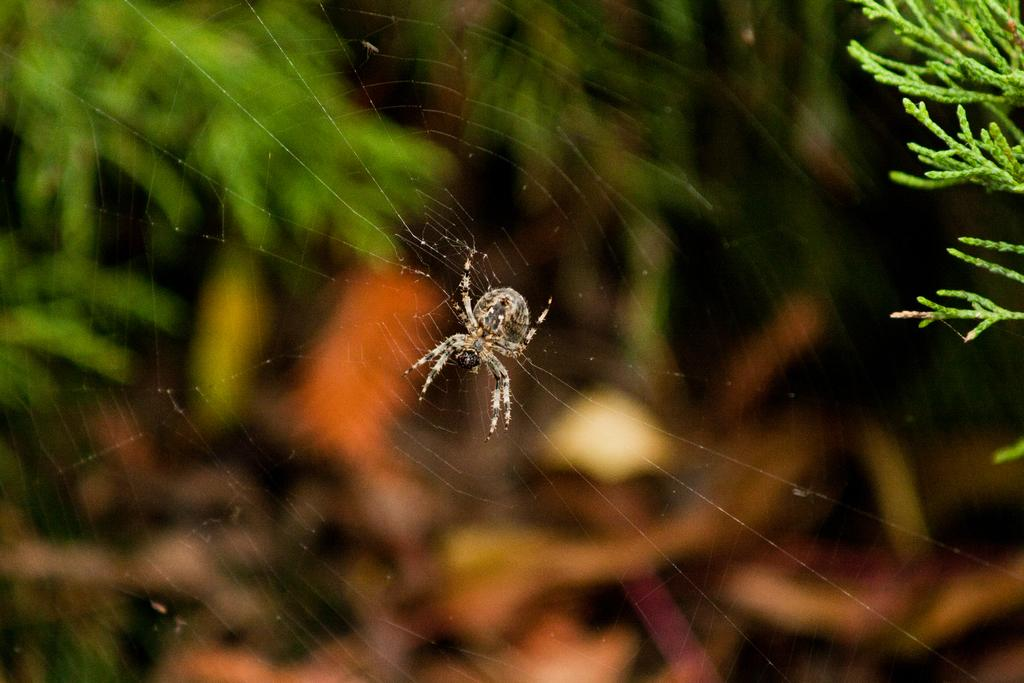What is the main subject of the image? The main subject of the image is a spider. Where is the spider located in the image? The spider is on a web. What can be seen on the right side of the image? There are leaves on the right side of the image. How would you describe the background of the image? The background of the image is blurry. What type of eggnog is being poured from the spider's web in the image? There is no eggnog present in the image; it features a spider on a web with leaves in the background. Can you hear the spider whistling in the image? There is no indication of sound in the image, and spiders do not have the ability to whistle. 